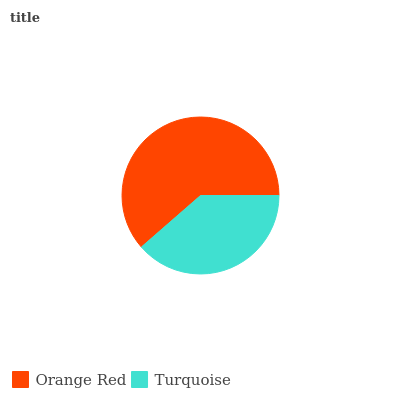Is Turquoise the minimum?
Answer yes or no. Yes. Is Orange Red the maximum?
Answer yes or no. Yes. Is Turquoise the maximum?
Answer yes or no. No. Is Orange Red greater than Turquoise?
Answer yes or no. Yes. Is Turquoise less than Orange Red?
Answer yes or no. Yes. Is Turquoise greater than Orange Red?
Answer yes or no. No. Is Orange Red less than Turquoise?
Answer yes or no. No. Is Orange Red the high median?
Answer yes or no. Yes. Is Turquoise the low median?
Answer yes or no. Yes. Is Turquoise the high median?
Answer yes or no. No. Is Orange Red the low median?
Answer yes or no. No. 